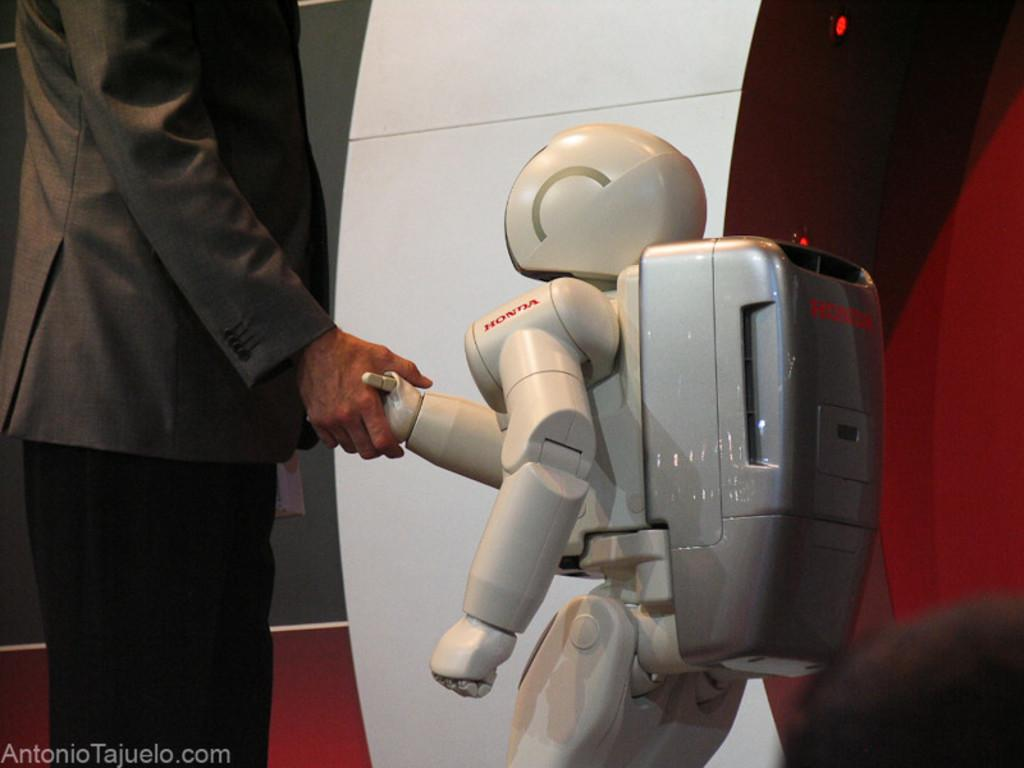What is the main subject of the image? The main subject of the image is a robot. What is the robot doing in the image? The robot is holding a human hand. What color is the robot in the image? The robot is white. What is the person wearing in the image? The person is wearing a brown blazer and black pants. Can you hear the rhythm of the music playing in the image? There is no music or sound mentioned in the image, so it's not possible to determine if there is a rhythm present. 